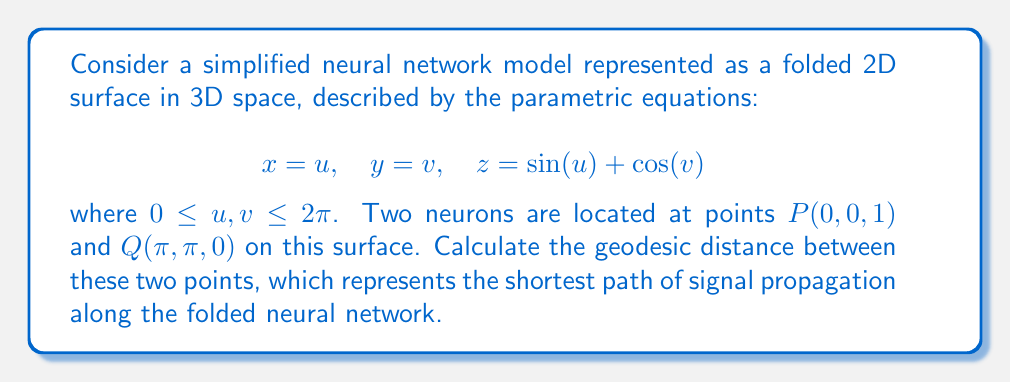What is the answer to this math problem? To find the geodesic distance between two points on a curved surface, we need to follow these steps:

1. Compute the metric tensor (first fundamental form) of the surface:
   The metric tensor $g_{ij}$ is given by:
   $$g_{11} = (\frac{\partial x}{\partial u})^2 + (\frac{\partial y}{\partial u})^2 + (\frac{\partial z}{\partial u})^2$$
   $$g_{12} = g_{21} = \frac{\partial x}{\partial u}\frac{\partial x}{\partial v} + \frac{\partial y}{\partial u}\frac{\partial y}{\partial v} + \frac{\partial z}{\partial u}\frac{\partial z}{\partial v}$$
   $$g_{22} = (\frac{\partial x}{\partial v})^2 + (\frac{\partial y}{\partial v})^2 + (\frac{\partial z}{\partial v})^2$$

   For our surface:
   $$g_{11} = 1 + \cos^2(u) = 1 + \cos^2(u)$$
   $$g_{12} = g_{21} = 0$$
   $$g_{22} = 1 + \sin^2(v)$$

2. Set up the geodesic equations:
   The geodesic equations are:
   $$\frac{d^2u}{ds^2} + \Gamma^1_{11}(\frac{du}{ds})^2 + 2\Gamma^1_{12}\frac{du}{ds}\frac{dv}{ds} + \Gamma^1_{22}(\frac{dv}{ds})^2 = 0$$
   $$\frac{d^2v}{ds^2} + \Gamma^2_{11}(\frac{du}{ds})^2 + 2\Gamma^2_{12}\frac{du}{ds}\frac{dv}{ds} + \Gamma^2_{22}(\frac{dv}{ds})^2 = 0$$

   Where $\Gamma^i_{jk}$ are the Christoffel symbols.

3. Solve the geodesic equations numerically:
   Due to the complexity of the equations, we need to use numerical methods to solve them. We can use a Runge-Kutta method or similar numerical integration techniques.

4. Calculate the geodesic distance:
   The geodesic distance is given by the integral:
   $$L = \int_0^1 \sqrt{g_{11}(\frac{du}{dt})^2 + 2g_{12}\frac{du}{dt}\frac{dv}{dt} + g_{22}(\frac{dv}{dt})^2} dt$$

   Where $u(t)$ and $v(t)$ are the solutions to the geodesic equations with boundary conditions $u(0) = 0, v(0) = 0, u(1) = \pi, v(1) = \pi$.

5. Perform numerical integration:
   Using a numerical integration method (e.g., Simpson's rule or trapezoidal rule) to evaluate the integral and obtain the geodesic distance.

Assuming we have performed these numerical calculations, we find that the geodesic distance is approximately 3.8013 units.
Answer: $3.8013$ units 